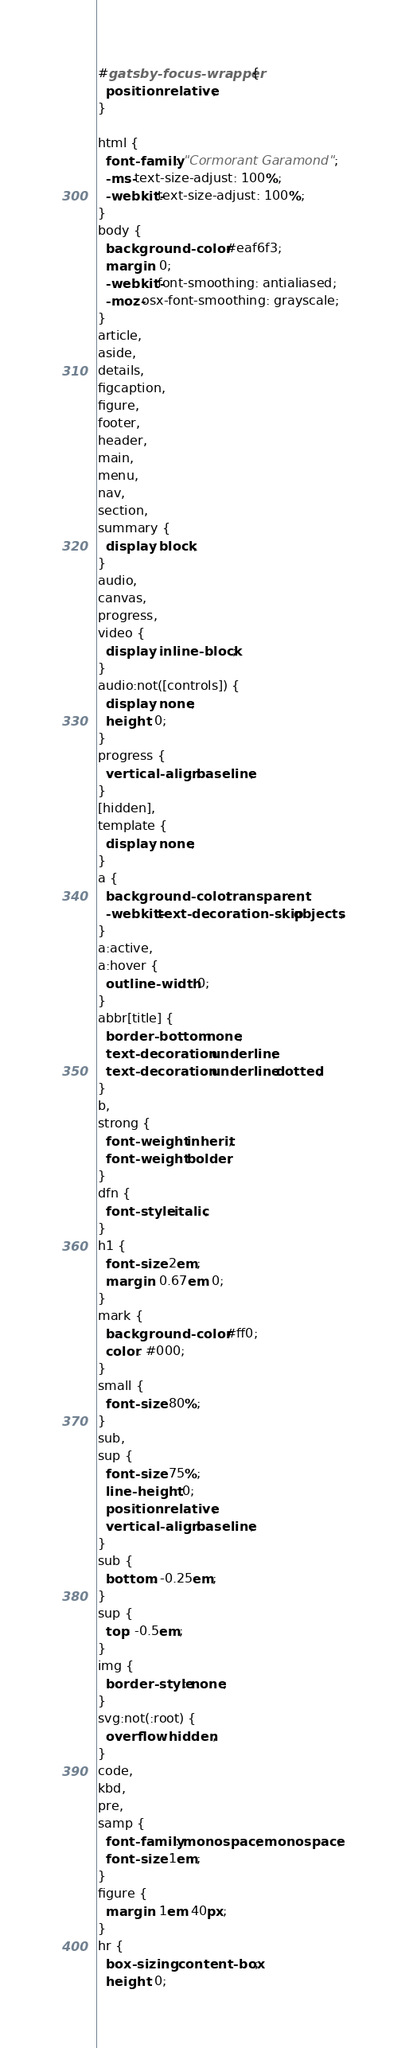Convert code to text. <code><loc_0><loc_0><loc_500><loc_500><_CSS_>#gatsby-focus-wrapper {
  position: relative;
}

html {
  font-family: "Cormorant Garamond";
  -ms-text-size-adjust: 100%;
  -webkit-text-size-adjust: 100%;
}
body {
  background-color: #eaf6f3;
  margin: 0;
  -webkit-font-smoothing: antialiased;
  -moz-osx-font-smoothing: grayscale;
}
article,
aside,
details,
figcaption,
figure,
footer,
header,
main,
menu,
nav,
section,
summary {
  display: block;
}
audio,
canvas,
progress,
video {
  display: inline-block;
}
audio:not([controls]) {
  display: none;
  height: 0;
}
progress {
  vertical-align: baseline;
}
[hidden],
template {
  display: none;
}
a {
  background-color: transparent;
  -webkit-text-decoration-skip: objects;
}
a:active,
a:hover {
  outline-width: 0;
}
abbr[title] {
  border-bottom: none;
  text-decoration: underline;
  text-decoration: underline dotted;
}
b,
strong {
  font-weight: inherit;
  font-weight: bolder;
}
dfn {
  font-style: italic;
}
h1 {
  font-size: 2em;
  margin: 0.67em 0;
}
mark {
  background-color: #ff0;
  color: #000;
}
small {
  font-size: 80%;
}
sub,
sup {
  font-size: 75%;
  line-height: 0;
  position: relative;
  vertical-align: baseline;
}
sub {
  bottom: -0.25em;
}
sup {
  top: -0.5em;
}
img {
  border-style: none;
}
svg:not(:root) {
  overflow: hidden;
}
code,
kbd,
pre,
samp {
  font-family: monospace, monospace;
  font-size: 1em;
}
figure {
  margin: 1em 40px;
}
hr {
  box-sizing: content-box;
  height: 0;</code> 